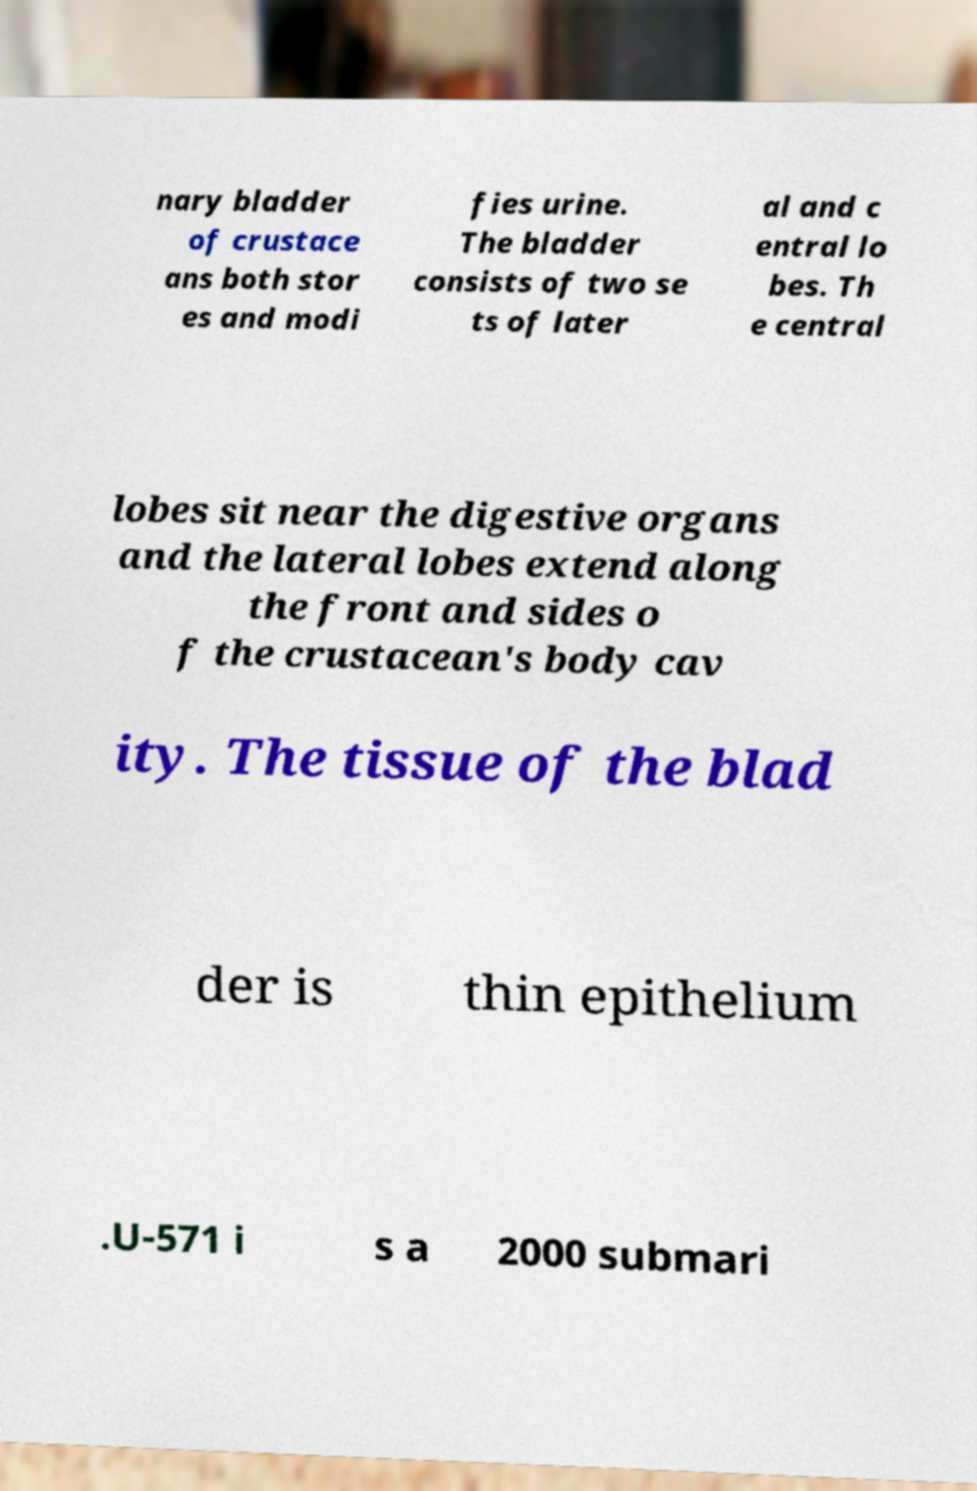I need the written content from this picture converted into text. Can you do that? nary bladder of crustace ans both stor es and modi fies urine. The bladder consists of two se ts of later al and c entral lo bes. Th e central lobes sit near the digestive organs and the lateral lobes extend along the front and sides o f the crustacean's body cav ity. The tissue of the blad der is thin epithelium .U-571 i s a 2000 submari 